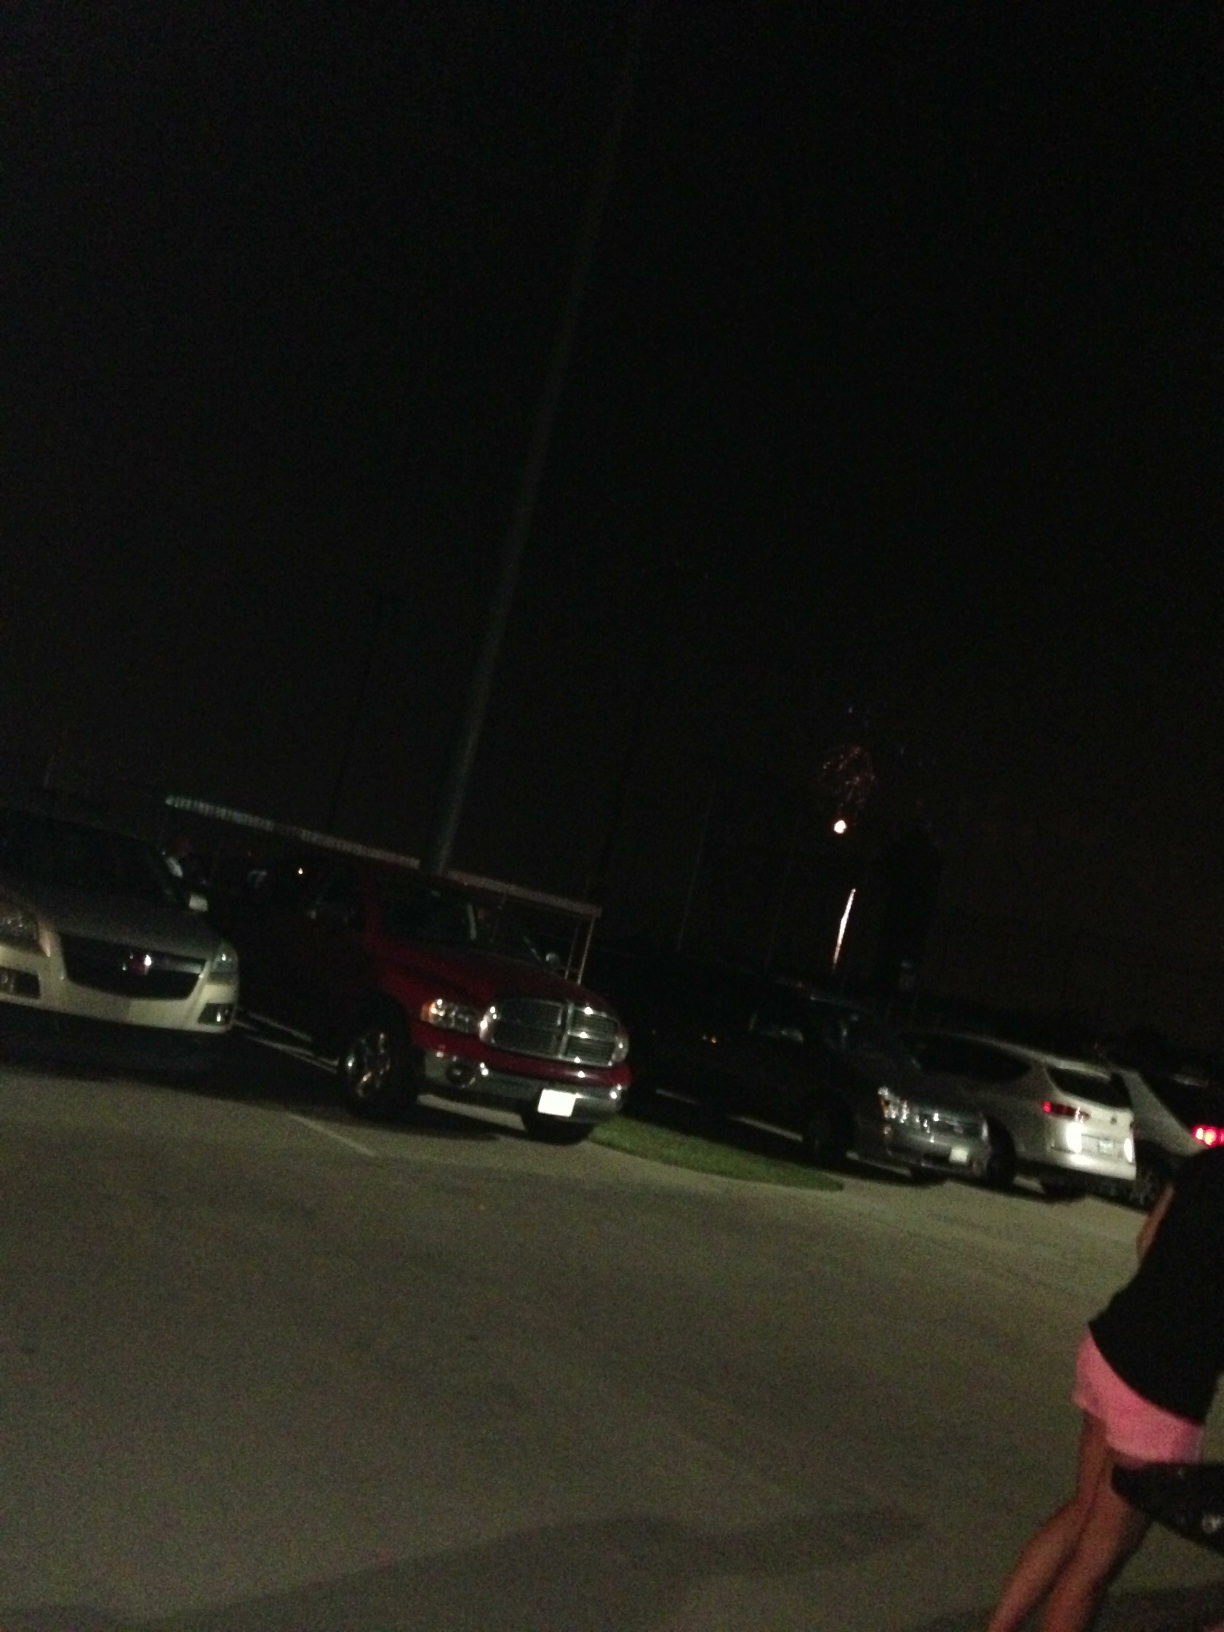What time of day is pictured in this image? This image is taken at night, as evident from the dark sky and artificial lighting in the parking lot. What does the presence of fireworks imply about the possible date or occasion? The fireworks typically suggest a celebration, such as New Year's Eve, Independence Day, or other local cultural or national festivities. 